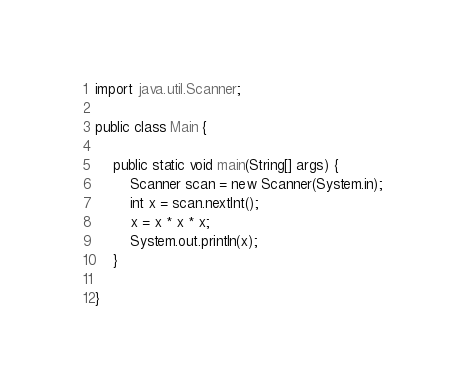Convert code to text. <code><loc_0><loc_0><loc_500><loc_500><_Java_>

import java.util.Scanner;

public class Main {

	public static void main(String[] args) {
		Scanner scan = new Scanner(System.in);  
		int x = scan.nextInt();
		x = x * x * x;
		System.out.println(x);
	}

}</code> 